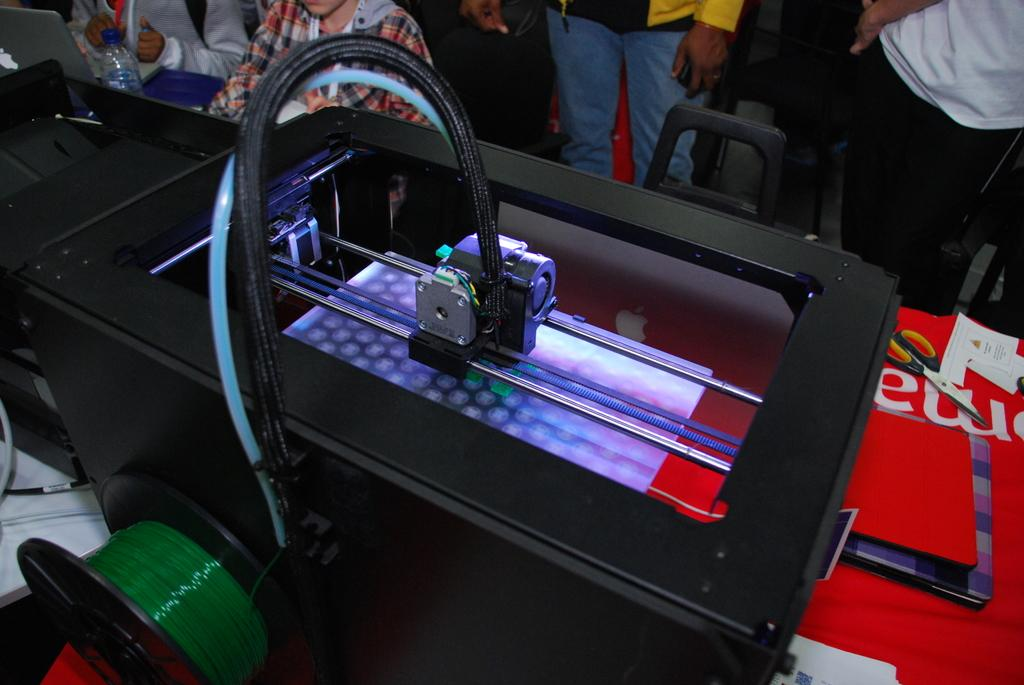What objects are on the table in the image? There are scissors, laptops, and papers on the table in the image. What type of items are present on the table that are related to technology? There are electronic devices and objects on the table. Can you describe the people and objects in the background of the image? There are people and chairs in the background, as well as a water bottle. What type of dinner is being served in the image? There is no dinner present in the image; it features a table with various objects and people in the background. 